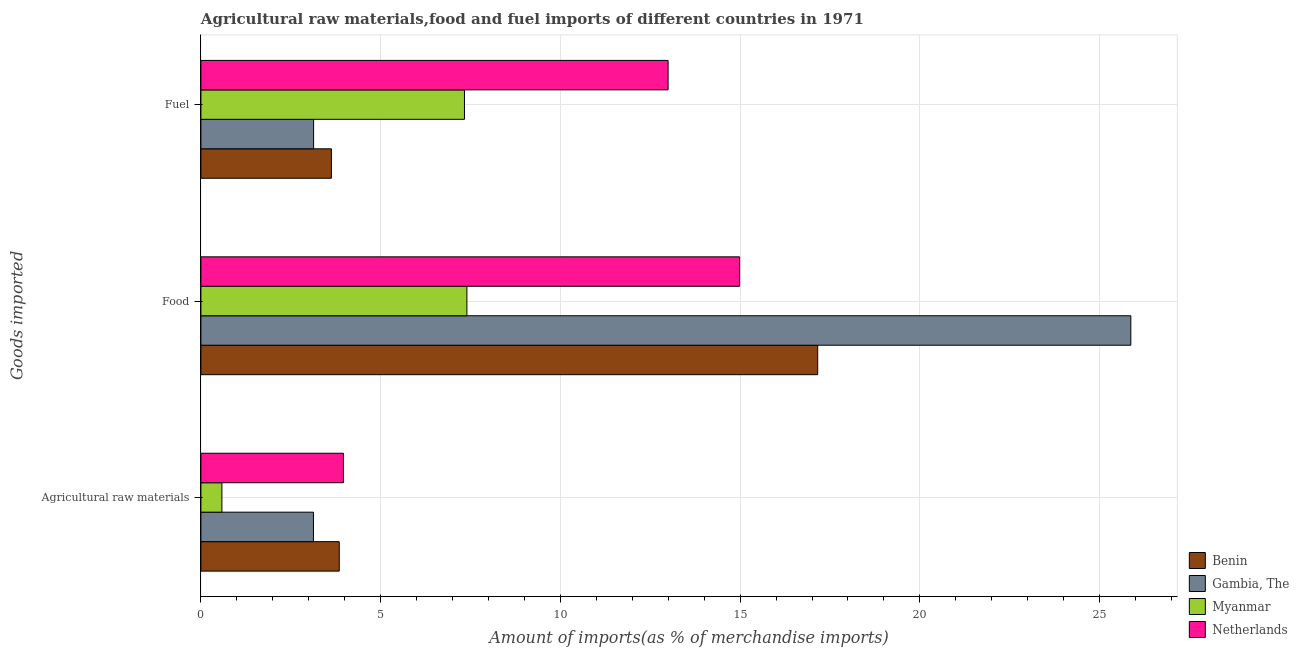How many groups of bars are there?
Offer a very short reply. 3. Are the number of bars per tick equal to the number of legend labels?
Offer a very short reply. Yes. How many bars are there on the 3rd tick from the bottom?
Your answer should be compact. 4. What is the label of the 1st group of bars from the top?
Your response must be concise. Fuel. What is the percentage of food imports in Gambia, The?
Provide a short and direct response. 25.87. Across all countries, what is the maximum percentage of raw materials imports?
Provide a short and direct response. 3.96. Across all countries, what is the minimum percentage of food imports?
Ensure brevity in your answer.  7.4. In which country was the percentage of food imports minimum?
Offer a very short reply. Myanmar. What is the total percentage of raw materials imports in the graph?
Offer a terse response. 11.53. What is the difference between the percentage of fuel imports in Gambia, The and that in Myanmar?
Make the answer very short. -4.2. What is the difference between the percentage of raw materials imports in Myanmar and the percentage of food imports in Netherlands?
Make the answer very short. -14.4. What is the average percentage of food imports per country?
Give a very brief answer. 16.35. What is the difference between the percentage of fuel imports and percentage of food imports in Gambia, The?
Offer a very short reply. -22.73. In how many countries, is the percentage of raw materials imports greater than 1 %?
Provide a short and direct response. 3. What is the ratio of the percentage of raw materials imports in Netherlands to that in Myanmar?
Your answer should be very brief. 6.79. Is the difference between the percentage of raw materials imports in Netherlands and Gambia, The greater than the difference between the percentage of food imports in Netherlands and Gambia, The?
Provide a succinct answer. Yes. What is the difference between the highest and the second highest percentage of raw materials imports?
Offer a terse response. 0.12. What is the difference between the highest and the lowest percentage of fuel imports?
Your answer should be very brief. 9.86. In how many countries, is the percentage of raw materials imports greater than the average percentage of raw materials imports taken over all countries?
Your response must be concise. 3. Is the sum of the percentage of food imports in Benin and Gambia, The greater than the maximum percentage of raw materials imports across all countries?
Keep it short and to the point. Yes. What does the 2nd bar from the top in Fuel represents?
Your response must be concise. Myanmar. Is it the case that in every country, the sum of the percentage of raw materials imports and percentage of food imports is greater than the percentage of fuel imports?
Your answer should be compact. Yes. How many bars are there?
Your answer should be compact. 12. What is the difference between two consecutive major ticks on the X-axis?
Give a very brief answer. 5. Does the graph contain any zero values?
Keep it short and to the point. No. How many legend labels are there?
Offer a very short reply. 4. What is the title of the graph?
Keep it short and to the point. Agricultural raw materials,food and fuel imports of different countries in 1971. What is the label or title of the X-axis?
Provide a succinct answer. Amount of imports(as % of merchandise imports). What is the label or title of the Y-axis?
Your answer should be very brief. Goods imported. What is the Amount of imports(as % of merchandise imports) of Benin in Agricultural raw materials?
Your answer should be compact. 3.85. What is the Amount of imports(as % of merchandise imports) in Gambia, The in Agricultural raw materials?
Your answer should be very brief. 3.13. What is the Amount of imports(as % of merchandise imports) in Myanmar in Agricultural raw materials?
Your answer should be very brief. 0.58. What is the Amount of imports(as % of merchandise imports) of Netherlands in Agricultural raw materials?
Ensure brevity in your answer.  3.96. What is the Amount of imports(as % of merchandise imports) of Benin in Food?
Offer a very short reply. 17.16. What is the Amount of imports(as % of merchandise imports) in Gambia, The in Food?
Give a very brief answer. 25.87. What is the Amount of imports(as % of merchandise imports) in Myanmar in Food?
Offer a very short reply. 7.4. What is the Amount of imports(as % of merchandise imports) in Netherlands in Food?
Your answer should be compact. 14.99. What is the Amount of imports(as % of merchandise imports) of Benin in Fuel?
Offer a very short reply. 3.63. What is the Amount of imports(as % of merchandise imports) of Gambia, The in Fuel?
Keep it short and to the point. 3.13. What is the Amount of imports(as % of merchandise imports) in Myanmar in Fuel?
Your answer should be compact. 7.33. What is the Amount of imports(as % of merchandise imports) in Netherlands in Fuel?
Your answer should be very brief. 13. Across all Goods imported, what is the maximum Amount of imports(as % of merchandise imports) of Benin?
Your answer should be very brief. 17.16. Across all Goods imported, what is the maximum Amount of imports(as % of merchandise imports) of Gambia, The?
Offer a very short reply. 25.87. Across all Goods imported, what is the maximum Amount of imports(as % of merchandise imports) of Myanmar?
Give a very brief answer. 7.4. Across all Goods imported, what is the maximum Amount of imports(as % of merchandise imports) of Netherlands?
Your answer should be compact. 14.99. Across all Goods imported, what is the minimum Amount of imports(as % of merchandise imports) of Benin?
Your response must be concise. 3.63. Across all Goods imported, what is the minimum Amount of imports(as % of merchandise imports) in Gambia, The?
Your answer should be compact. 3.13. Across all Goods imported, what is the minimum Amount of imports(as % of merchandise imports) in Myanmar?
Your answer should be very brief. 0.58. Across all Goods imported, what is the minimum Amount of imports(as % of merchandise imports) of Netherlands?
Your answer should be compact. 3.96. What is the total Amount of imports(as % of merchandise imports) in Benin in the graph?
Keep it short and to the point. 24.64. What is the total Amount of imports(as % of merchandise imports) in Gambia, The in the graph?
Make the answer very short. 32.13. What is the total Amount of imports(as % of merchandise imports) in Myanmar in the graph?
Your response must be concise. 15.32. What is the total Amount of imports(as % of merchandise imports) of Netherlands in the graph?
Keep it short and to the point. 31.95. What is the difference between the Amount of imports(as % of merchandise imports) in Benin in Agricultural raw materials and that in Food?
Make the answer very short. -13.31. What is the difference between the Amount of imports(as % of merchandise imports) in Gambia, The in Agricultural raw materials and that in Food?
Your answer should be compact. -22.74. What is the difference between the Amount of imports(as % of merchandise imports) of Myanmar in Agricultural raw materials and that in Food?
Your answer should be very brief. -6.82. What is the difference between the Amount of imports(as % of merchandise imports) in Netherlands in Agricultural raw materials and that in Food?
Provide a short and direct response. -11.02. What is the difference between the Amount of imports(as % of merchandise imports) in Benin in Agricultural raw materials and that in Fuel?
Give a very brief answer. 0.22. What is the difference between the Amount of imports(as % of merchandise imports) of Gambia, The in Agricultural raw materials and that in Fuel?
Offer a terse response. -0. What is the difference between the Amount of imports(as % of merchandise imports) of Myanmar in Agricultural raw materials and that in Fuel?
Keep it short and to the point. -6.75. What is the difference between the Amount of imports(as % of merchandise imports) in Netherlands in Agricultural raw materials and that in Fuel?
Ensure brevity in your answer.  -9.03. What is the difference between the Amount of imports(as % of merchandise imports) in Benin in Food and that in Fuel?
Offer a very short reply. 13.53. What is the difference between the Amount of imports(as % of merchandise imports) of Gambia, The in Food and that in Fuel?
Your answer should be compact. 22.73. What is the difference between the Amount of imports(as % of merchandise imports) in Myanmar in Food and that in Fuel?
Ensure brevity in your answer.  0.07. What is the difference between the Amount of imports(as % of merchandise imports) of Netherlands in Food and that in Fuel?
Offer a terse response. 1.99. What is the difference between the Amount of imports(as % of merchandise imports) of Benin in Agricultural raw materials and the Amount of imports(as % of merchandise imports) of Gambia, The in Food?
Your answer should be compact. -22.02. What is the difference between the Amount of imports(as % of merchandise imports) in Benin in Agricultural raw materials and the Amount of imports(as % of merchandise imports) in Myanmar in Food?
Offer a terse response. -3.55. What is the difference between the Amount of imports(as % of merchandise imports) of Benin in Agricultural raw materials and the Amount of imports(as % of merchandise imports) of Netherlands in Food?
Make the answer very short. -11.14. What is the difference between the Amount of imports(as % of merchandise imports) of Gambia, The in Agricultural raw materials and the Amount of imports(as % of merchandise imports) of Myanmar in Food?
Offer a very short reply. -4.27. What is the difference between the Amount of imports(as % of merchandise imports) of Gambia, The in Agricultural raw materials and the Amount of imports(as % of merchandise imports) of Netherlands in Food?
Your answer should be compact. -11.86. What is the difference between the Amount of imports(as % of merchandise imports) in Myanmar in Agricultural raw materials and the Amount of imports(as % of merchandise imports) in Netherlands in Food?
Give a very brief answer. -14.4. What is the difference between the Amount of imports(as % of merchandise imports) in Benin in Agricultural raw materials and the Amount of imports(as % of merchandise imports) in Gambia, The in Fuel?
Give a very brief answer. 0.71. What is the difference between the Amount of imports(as % of merchandise imports) of Benin in Agricultural raw materials and the Amount of imports(as % of merchandise imports) of Myanmar in Fuel?
Keep it short and to the point. -3.48. What is the difference between the Amount of imports(as % of merchandise imports) in Benin in Agricultural raw materials and the Amount of imports(as % of merchandise imports) in Netherlands in Fuel?
Offer a terse response. -9.15. What is the difference between the Amount of imports(as % of merchandise imports) of Gambia, The in Agricultural raw materials and the Amount of imports(as % of merchandise imports) of Myanmar in Fuel?
Offer a terse response. -4.2. What is the difference between the Amount of imports(as % of merchandise imports) in Gambia, The in Agricultural raw materials and the Amount of imports(as % of merchandise imports) in Netherlands in Fuel?
Your response must be concise. -9.87. What is the difference between the Amount of imports(as % of merchandise imports) in Myanmar in Agricultural raw materials and the Amount of imports(as % of merchandise imports) in Netherlands in Fuel?
Provide a short and direct response. -12.41. What is the difference between the Amount of imports(as % of merchandise imports) in Benin in Food and the Amount of imports(as % of merchandise imports) in Gambia, The in Fuel?
Your response must be concise. 14.02. What is the difference between the Amount of imports(as % of merchandise imports) of Benin in Food and the Amount of imports(as % of merchandise imports) of Myanmar in Fuel?
Give a very brief answer. 9.83. What is the difference between the Amount of imports(as % of merchandise imports) of Benin in Food and the Amount of imports(as % of merchandise imports) of Netherlands in Fuel?
Ensure brevity in your answer.  4.16. What is the difference between the Amount of imports(as % of merchandise imports) in Gambia, The in Food and the Amount of imports(as % of merchandise imports) in Myanmar in Fuel?
Your answer should be very brief. 18.54. What is the difference between the Amount of imports(as % of merchandise imports) in Gambia, The in Food and the Amount of imports(as % of merchandise imports) in Netherlands in Fuel?
Offer a very short reply. 12.87. What is the difference between the Amount of imports(as % of merchandise imports) in Myanmar in Food and the Amount of imports(as % of merchandise imports) in Netherlands in Fuel?
Provide a succinct answer. -5.6. What is the average Amount of imports(as % of merchandise imports) in Benin per Goods imported?
Ensure brevity in your answer.  8.21. What is the average Amount of imports(as % of merchandise imports) in Gambia, The per Goods imported?
Your response must be concise. 10.71. What is the average Amount of imports(as % of merchandise imports) of Myanmar per Goods imported?
Your answer should be compact. 5.11. What is the average Amount of imports(as % of merchandise imports) in Netherlands per Goods imported?
Provide a short and direct response. 10.65. What is the difference between the Amount of imports(as % of merchandise imports) of Benin and Amount of imports(as % of merchandise imports) of Gambia, The in Agricultural raw materials?
Ensure brevity in your answer.  0.72. What is the difference between the Amount of imports(as % of merchandise imports) in Benin and Amount of imports(as % of merchandise imports) in Myanmar in Agricultural raw materials?
Offer a very short reply. 3.26. What is the difference between the Amount of imports(as % of merchandise imports) in Benin and Amount of imports(as % of merchandise imports) in Netherlands in Agricultural raw materials?
Keep it short and to the point. -0.12. What is the difference between the Amount of imports(as % of merchandise imports) of Gambia, The and Amount of imports(as % of merchandise imports) of Myanmar in Agricultural raw materials?
Ensure brevity in your answer.  2.55. What is the difference between the Amount of imports(as % of merchandise imports) in Gambia, The and Amount of imports(as % of merchandise imports) in Netherlands in Agricultural raw materials?
Your answer should be very brief. -0.83. What is the difference between the Amount of imports(as % of merchandise imports) of Myanmar and Amount of imports(as % of merchandise imports) of Netherlands in Agricultural raw materials?
Your answer should be very brief. -3.38. What is the difference between the Amount of imports(as % of merchandise imports) of Benin and Amount of imports(as % of merchandise imports) of Gambia, The in Food?
Keep it short and to the point. -8.71. What is the difference between the Amount of imports(as % of merchandise imports) in Benin and Amount of imports(as % of merchandise imports) in Myanmar in Food?
Keep it short and to the point. 9.76. What is the difference between the Amount of imports(as % of merchandise imports) in Benin and Amount of imports(as % of merchandise imports) in Netherlands in Food?
Your response must be concise. 2.17. What is the difference between the Amount of imports(as % of merchandise imports) of Gambia, The and Amount of imports(as % of merchandise imports) of Myanmar in Food?
Ensure brevity in your answer.  18.47. What is the difference between the Amount of imports(as % of merchandise imports) in Gambia, The and Amount of imports(as % of merchandise imports) in Netherlands in Food?
Make the answer very short. 10.88. What is the difference between the Amount of imports(as % of merchandise imports) in Myanmar and Amount of imports(as % of merchandise imports) in Netherlands in Food?
Your response must be concise. -7.59. What is the difference between the Amount of imports(as % of merchandise imports) of Benin and Amount of imports(as % of merchandise imports) of Gambia, The in Fuel?
Make the answer very short. 0.5. What is the difference between the Amount of imports(as % of merchandise imports) of Benin and Amount of imports(as % of merchandise imports) of Myanmar in Fuel?
Offer a terse response. -3.7. What is the difference between the Amount of imports(as % of merchandise imports) of Benin and Amount of imports(as % of merchandise imports) of Netherlands in Fuel?
Provide a short and direct response. -9.37. What is the difference between the Amount of imports(as % of merchandise imports) of Gambia, The and Amount of imports(as % of merchandise imports) of Myanmar in Fuel?
Make the answer very short. -4.2. What is the difference between the Amount of imports(as % of merchandise imports) in Gambia, The and Amount of imports(as % of merchandise imports) in Netherlands in Fuel?
Your answer should be compact. -9.86. What is the difference between the Amount of imports(as % of merchandise imports) of Myanmar and Amount of imports(as % of merchandise imports) of Netherlands in Fuel?
Keep it short and to the point. -5.66. What is the ratio of the Amount of imports(as % of merchandise imports) of Benin in Agricultural raw materials to that in Food?
Give a very brief answer. 0.22. What is the ratio of the Amount of imports(as % of merchandise imports) of Gambia, The in Agricultural raw materials to that in Food?
Provide a short and direct response. 0.12. What is the ratio of the Amount of imports(as % of merchandise imports) in Myanmar in Agricultural raw materials to that in Food?
Your answer should be compact. 0.08. What is the ratio of the Amount of imports(as % of merchandise imports) of Netherlands in Agricultural raw materials to that in Food?
Provide a succinct answer. 0.26. What is the ratio of the Amount of imports(as % of merchandise imports) of Benin in Agricultural raw materials to that in Fuel?
Make the answer very short. 1.06. What is the ratio of the Amount of imports(as % of merchandise imports) in Gambia, The in Agricultural raw materials to that in Fuel?
Make the answer very short. 1. What is the ratio of the Amount of imports(as % of merchandise imports) of Myanmar in Agricultural raw materials to that in Fuel?
Your response must be concise. 0.08. What is the ratio of the Amount of imports(as % of merchandise imports) in Netherlands in Agricultural raw materials to that in Fuel?
Your answer should be compact. 0.3. What is the ratio of the Amount of imports(as % of merchandise imports) in Benin in Food to that in Fuel?
Your answer should be compact. 4.73. What is the ratio of the Amount of imports(as % of merchandise imports) of Gambia, The in Food to that in Fuel?
Your answer should be compact. 8.25. What is the ratio of the Amount of imports(as % of merchandise imports) of Myanmar in Food to that in Fuel?
Your response must be concise. 1.01. What is the ratio of the Amount of imports(as % of merchandise imports) in Netherlands in Food to that in Fuel?
Provide a succinct answer. 1.15. What is the difference between the highest and the second highest Amount of imports(as % of merchandise imports) in Benin?
Give a very brief answer. 13.31. What is the difference between the highest and the second highest Amount of imports(as % of merchandise imports) in Gambia, The?
Offer a terse response. 22.73. What is the difference between the highest and the second highest Amount of imports(as % of merchandise imports) of Myanmar?
Offer a terse response. 0.07. What is the difference between the highest and the second highest Amount of imports(as % of merchandise imports) in Netherlands?
Offer a very short reply. 1.99. What is the difference between the highest and the lowest Amount of imports(as % of merchandise imports) in Benin?
Give a very brief answer. 13.53. What is the difference between the highest and the lowest Amount of imports(as % of merchandise imports) in Gambia, The?
Offer a terse response. 22.74. What is the difference between the highest and the lowest Amount of imports(as % of merchandise imports) in Myanmar?
Your answer should be very brief. 6.82. What is the difference between the highest and the lowest Amount of imports(as % of merchandise imports) in Netherlands?
Give a very brief answer. 11.02. 